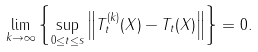<formula> <loc_0><loc_0><loc_500><loc_500>\lim _ { k \to \infty } \left \{ \sup _ { 0 \leq t \leq s } \left \| T _ { t } ^ { ( k ) } ( X ) - T _ { t } ( X ) \right \| \right \} = 0 .</formula> 